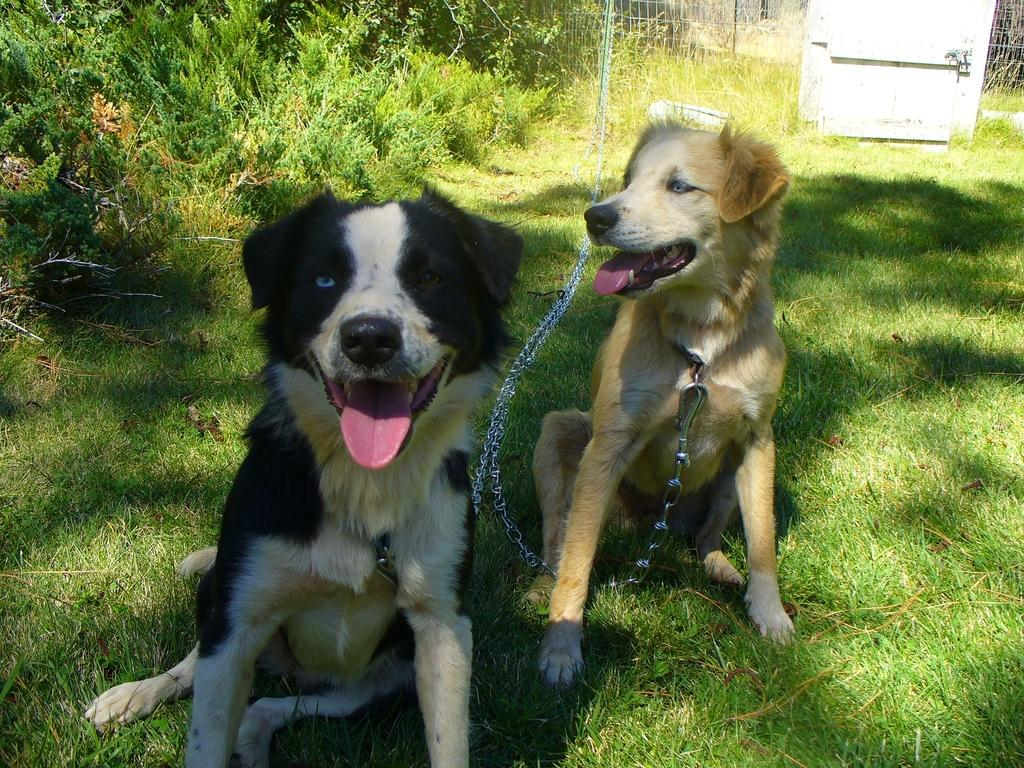How many dogs are present in the image? There are two dogs in the image. What are the dogs wearing? The dogs are wearing dog belts. What type of vegetation can be seen in the image? There are plants and grass in the image. What is visible in the background of the image? There is a fence and an object in the background of the image. What type of spark can be seen coming from the dog's collar in the image? There is no spark visible in the image, nor is there any indication that the dog's collar is producing a spark. 